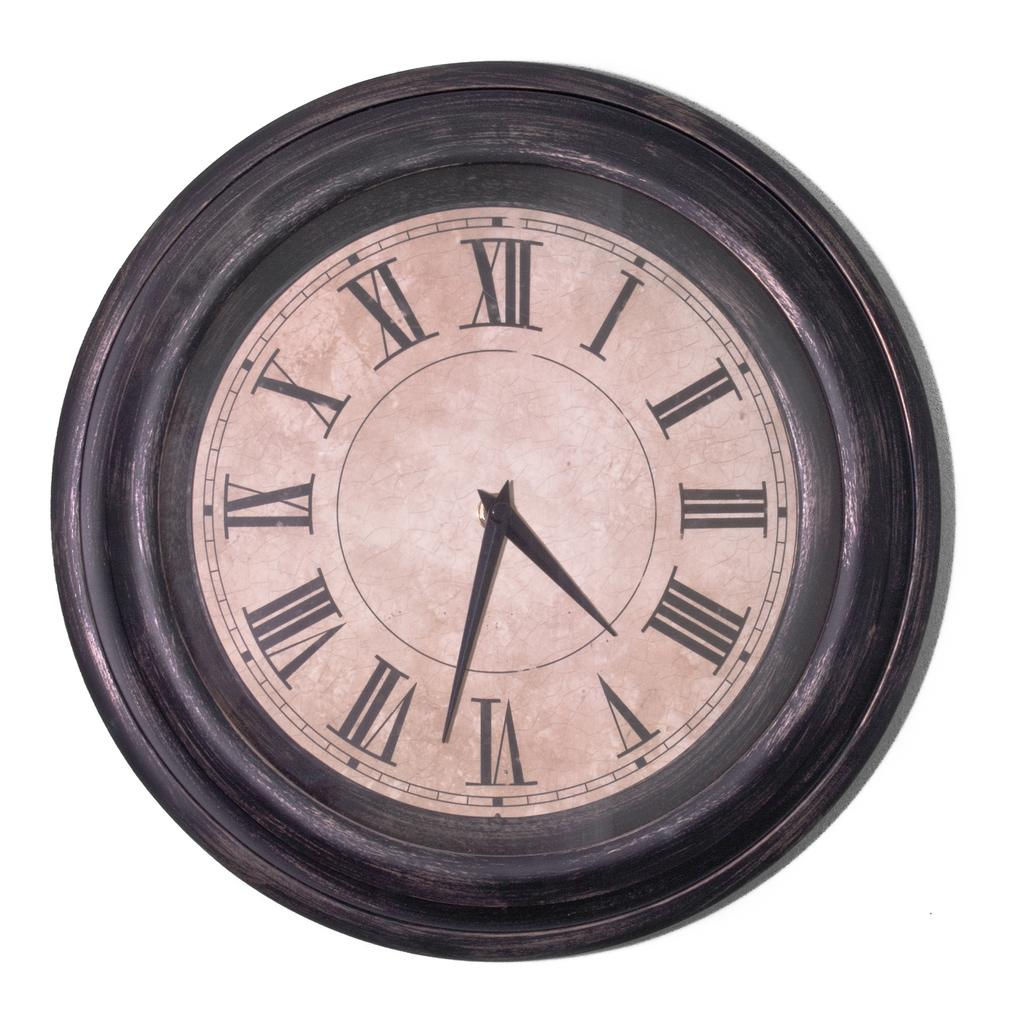<image>
Share a concise interpretation of the image provided. A clock with the hour hand between the roman numerals "IIII" and "V" 